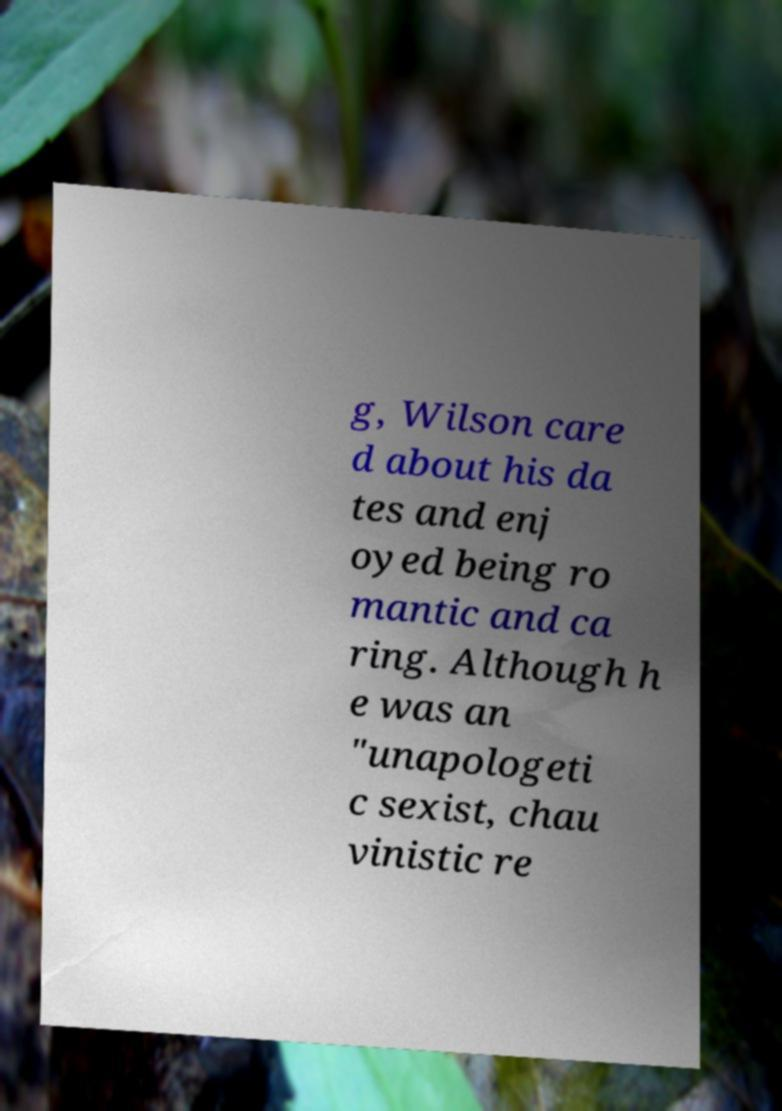There's text embedded in this image that I need extracted. Can you transcribe it verbatim? g, Wilson care d about his da tes and enj oyed being ro mantic and ca ring. Although h e was an "unapologeti c sexist, chau vinistic re 